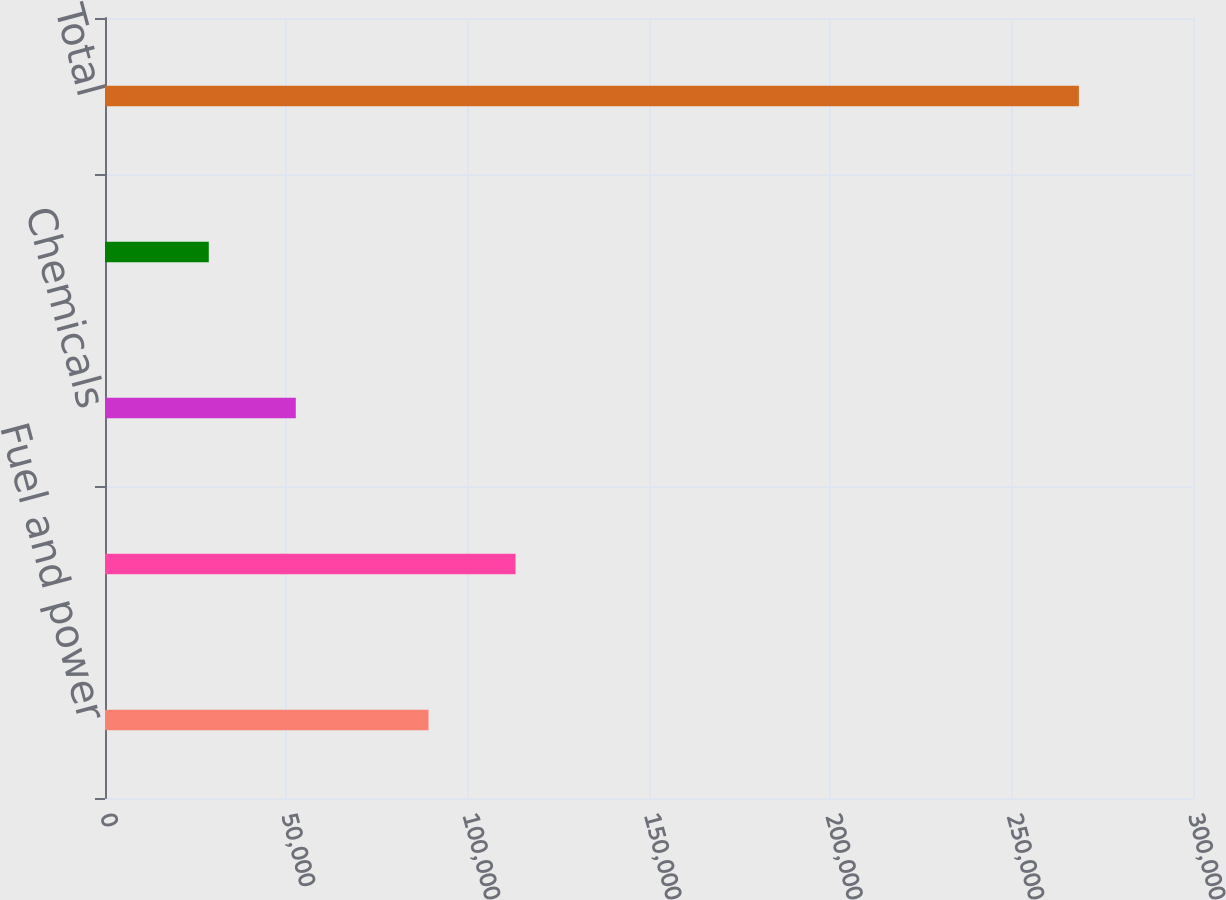Convert chart. <chart><loc_0><loc_0><loc_500><loc_500><bar_chart><fcel>Fuel and power<fcel>Purchased water<fcel>Chemicals<fcel>Waste disposal<fcel>Total<nl><fcel>89203<fcel>113194<fcel>52608.2<fcel>28617<fcel>268529<nl></chart> 